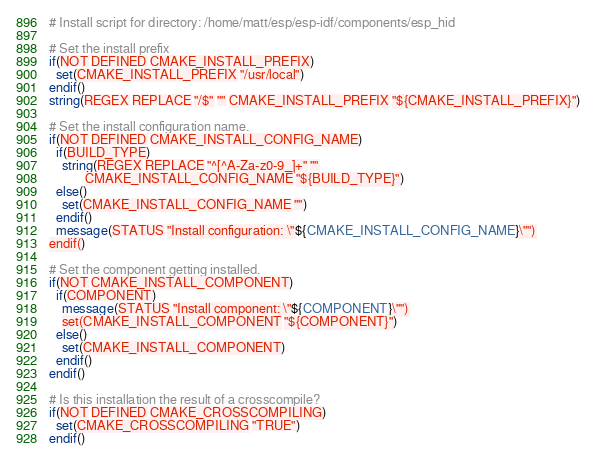Convert code to text. <code><loc_0><loc_0><loc_500><loc_500><_CMake_># Install script for directory: /home/matt/esp/esp-idf/components/esp_hid

# Set the install prefix
if(NOT DEFINED CMAKE_INSTALL_PREFIX)
  set(CMAKE_INSTALL_PREFIX "/usr/local")
endif()
string(REGEX REPLACE "/$" "" CMAKE_INSTALL_PREFIX "${CMAKE_INSTALL_PREFIX}")

# Set the install configuration name.
if(NOT DEFINED CMAKE_INSTALL_CONFIG_NAME)
  if(BUILD_TYPE)
    string(REGEX REPLACE "^[^A-Za-z0-9_]+" ""
           CMAKE_INSTALL_CONFIG_NAME "${BUILD_TYPE}")
  else()
    set(CMAKE_INSTALL_CONFIG_NAME "")
  endif()
  message(STATUS "Install configuration: \"${CMAKE_INSTALL_CONFIG_NAME}\"")
endif()

# Set the component getting installed.
if(NOT CMAKE_INSTALL_COMPONENT)
  if(COMPONENT)
    message(STATUS "Install component: \"${COMPONENT}\"")
    set(CMAKE_INSTALL_COMPONENT "${COMPONENT}")
  else()
    set(CMAKE_INSTALL_COMPONENT)
  endif()
endif()

# Is this installation the result of a crosscompile?
if(NOT DEFINED CMAKE_CROSSCOMPILING)
  set(CMAKE_CROSSCOMPILING "TRUE")
endif()

</code> 